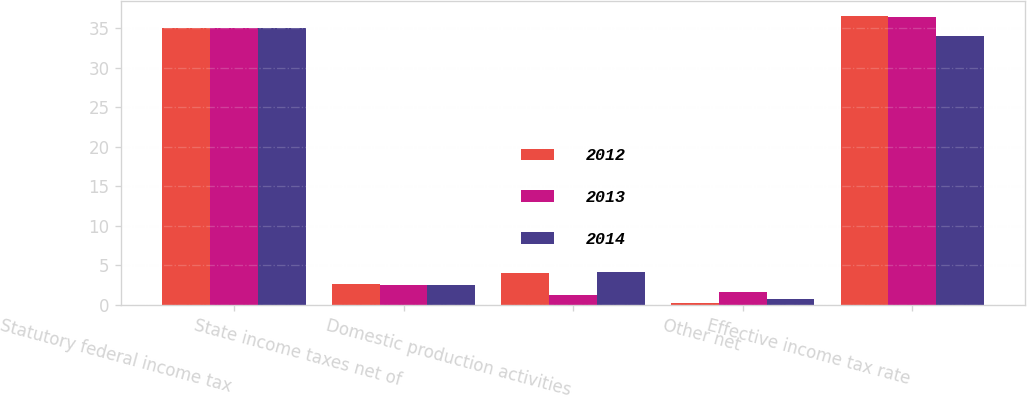Convert chart. <chart><loc_0><loc_0><loc_500><loc_500><stacked_bar_chart><ecel><fcel>Statutory federal income tax<fcel>State income taxes net of<fcel>Domestic production activities<fcel>Other net<fcel>Effective income tax rate<nl><fcel>2012<fcel>35<fcel>2.6<fcel>4.1<fcel>0.3<fcel>36.6<nl><fcel>2013<fcel>35<fcel>2.5<fcel>1.3<fcel>1.6<fcel>36.5<nl><fcel>2014<fcel>35<fcel>2.5<fcel>4.2<fcel>0.7<fcel>34<nl></chart> 